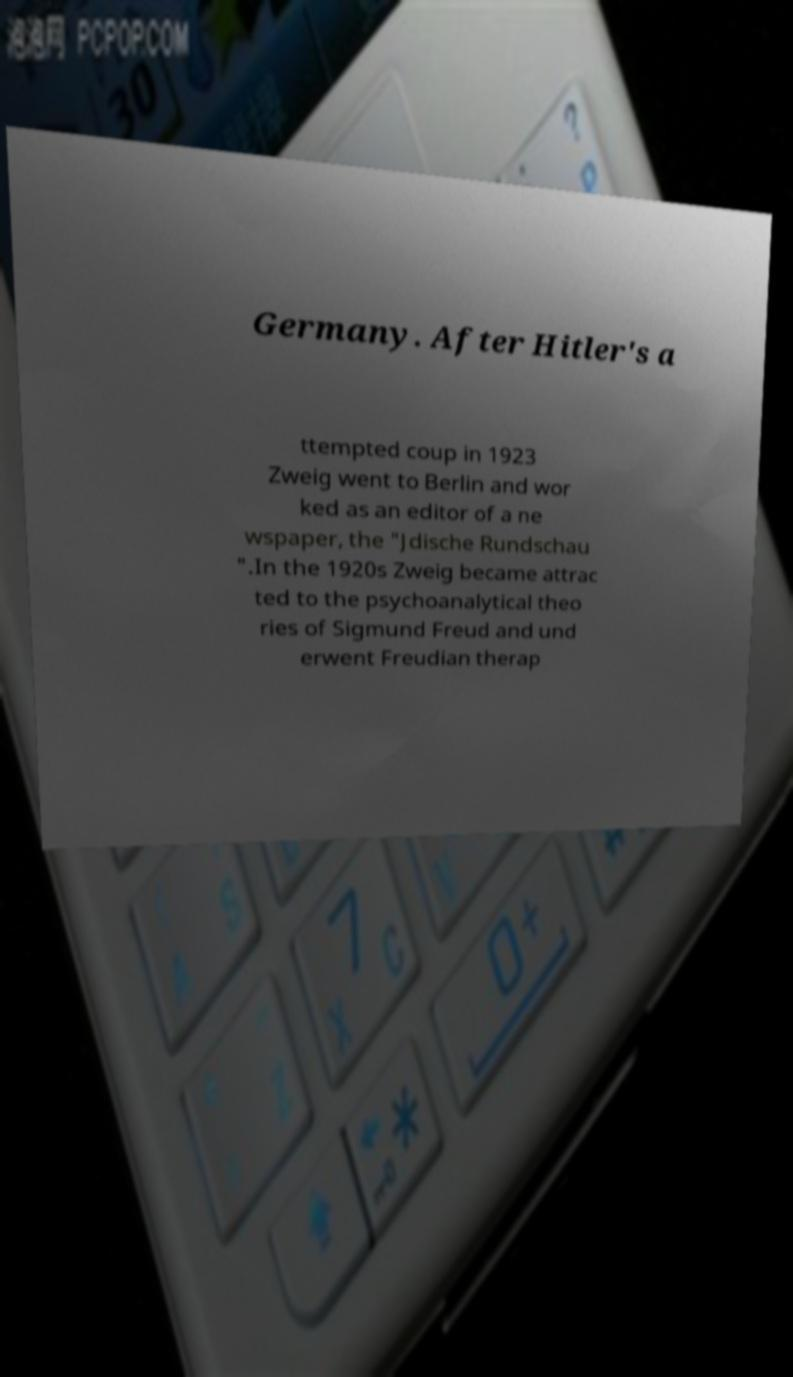There's text embedded in this image that I need extracted. Can you transcribe it verbatim? Germany. After Hitler's a ttempted coup in 1923 Zweig went to Berlin and wor ked as an editor of a ne wspaper, the "Jdische Rundschau ".In the 1920s Zweig became attrac ted to the psychoanalytical theo ries of Sigmund Freud and und erwent Freudian therap 